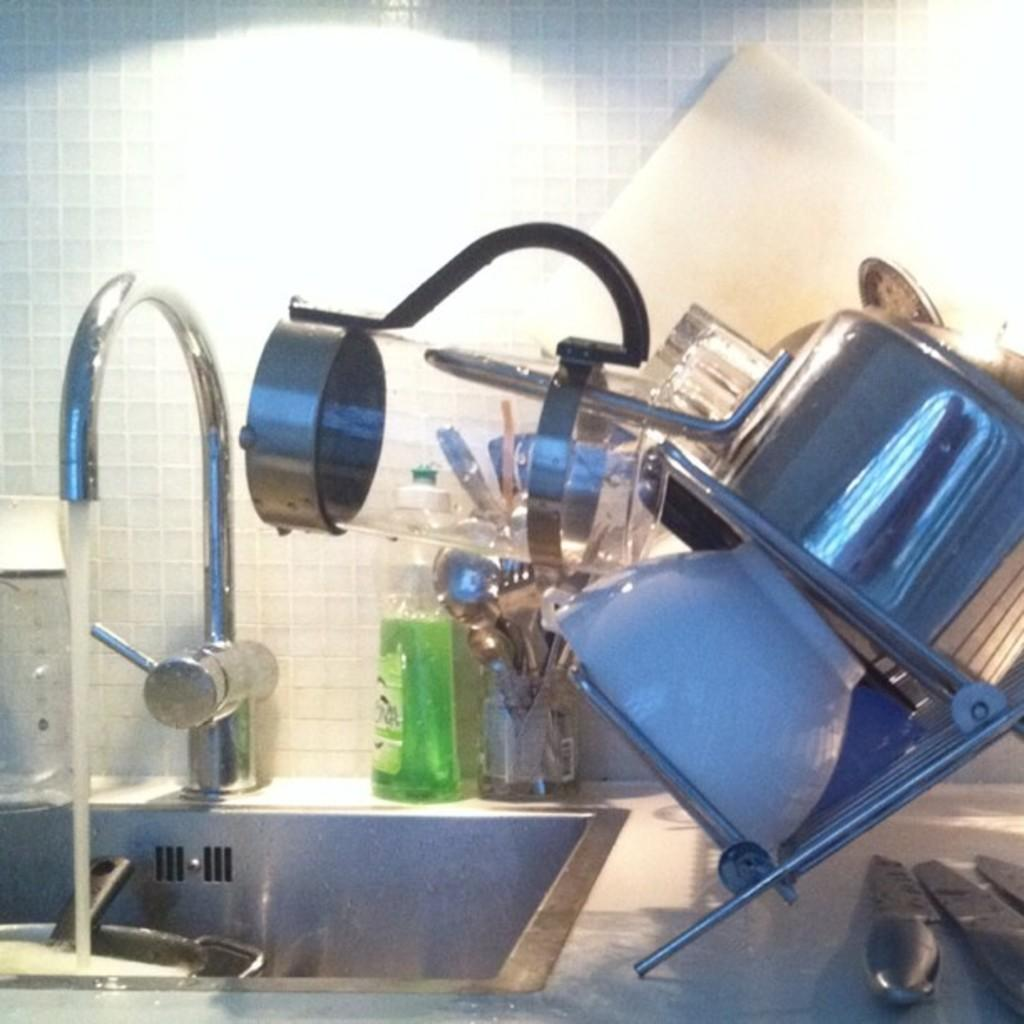What type of furniture is present in the image? There is a kitchen cabinet in the image. What can be found near the kitchen cabinet? There is a sink in the image. What is attached to the sink? There is a tap in the image. What items might be used for cooking or food preparation in the image? Kitchen tools and vessels are present in the image. What is the source of light in the image? There is a light in the image. What type of room might the image be taken in? The image is likely taken in a room, possibly a kitchen. How many eggs are visible in the image? There are no eggs present in the image. What type of wave can be seen crashing on the shore in the image? There is no shore or wave present in the image; it is a kitchen setting. 